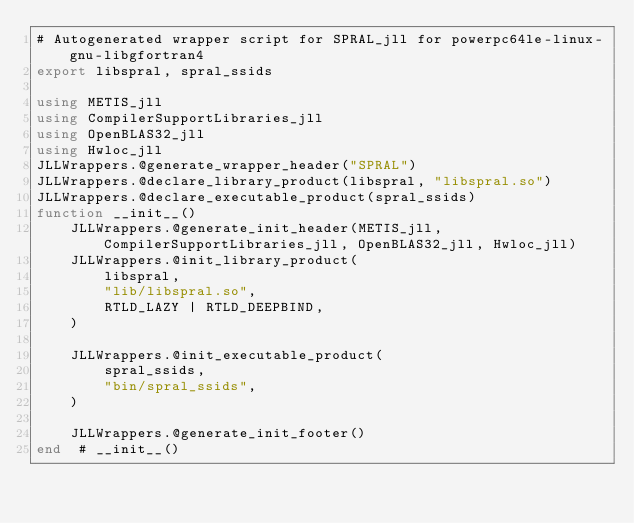<code> <loc_0><loc_0><loc_500><loc_500><_Julia_># Autogenerated wrapper script for SPRAL_jll for powerpc64le-linux-gnu-libgfortran4
export libspral, spral_ssids

using METIS_jll
using CompilerSupportLibraries_jll
using OpenBLAS32_jll
using Hwloc_jll
JLLWrappers.@generate_wrapper_header("SPRAL")
JLLWrappers.@declare_library_product(libspral, "libspral.so")
JLLWrappers.@declare_executable_product(spral_ssids)
function __init__()
    JLLWrappers.@generate_init_header(METIS_jll, CompilerSupportLibraries_jll, OpenBLAS32_jll, Hwloc_jll)
    JLLWrappers.@init_library_product(
        libspral,
        "lib/libspral.so",
        RTLD_LAZY | RTLD_DEEPBIND,
    )

    JLLWrappers.@init_executable_product(
        spral_ssids,
        "bin/spral_ssids",
    )

    JLLWrappers.@generate_init_footer()
end  # __init__()
</code> 